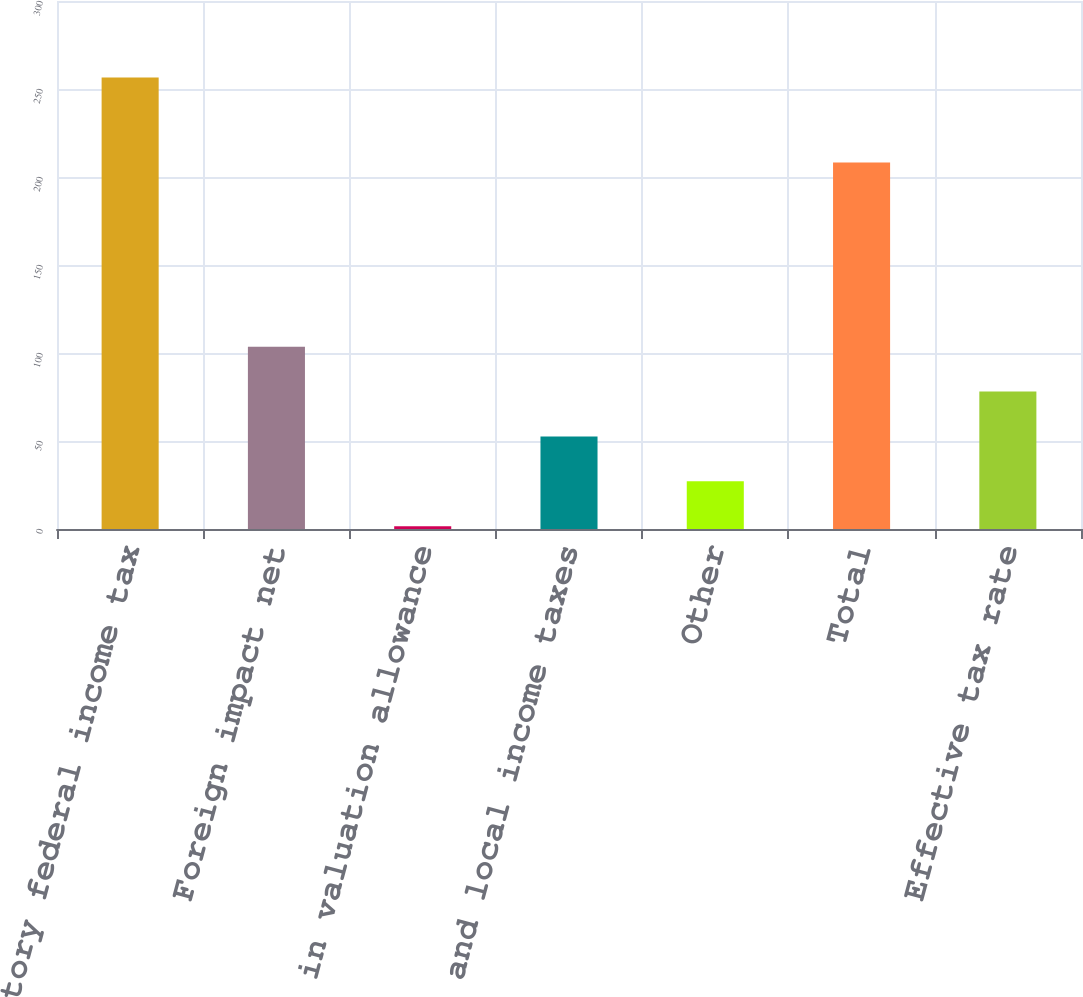<chart> <loc_0><loc_0><loc_500><loc_500><bar_chart><fcel>Statutory federal income tax<fcel>Foreign impact net<fcel>Change in valuation allowance<fcel>State and local income taxes<fcel>Other<fcel>Total<fcel>Effective tax rate<nl><fcel>256.6<fcel>103.6<fcel>1.6<fcel>52.6<fcel>27.1<fcel>208.3<fcel>78.1<nl></chart> 